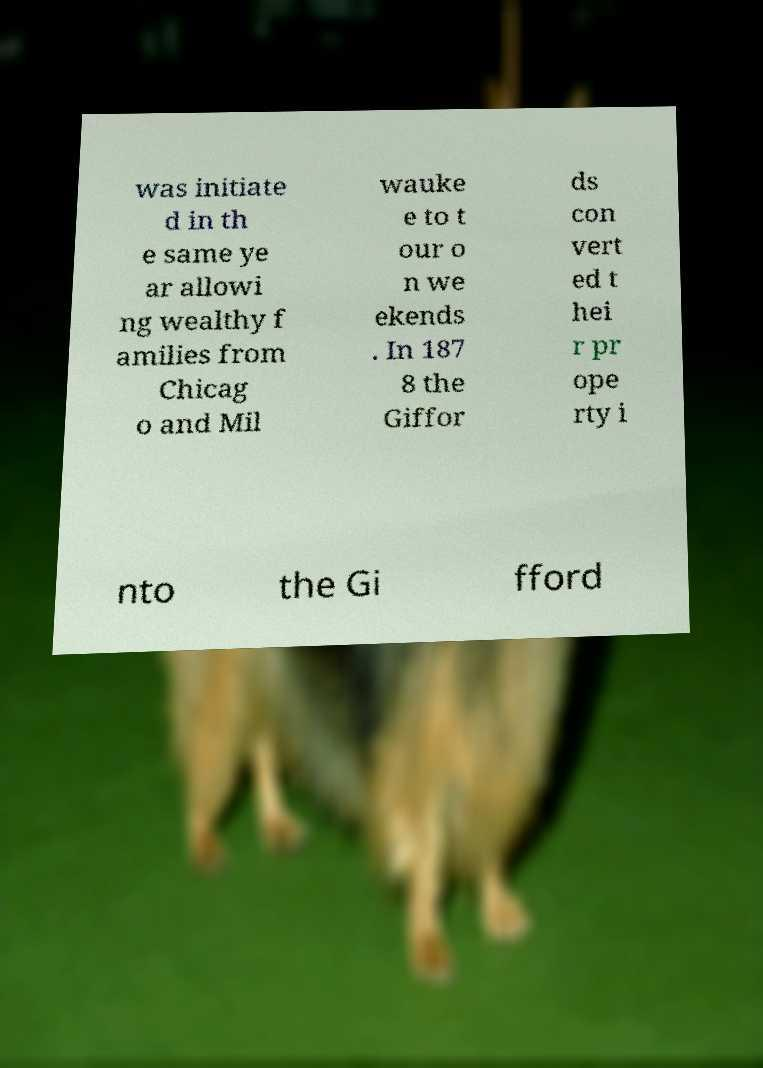I need the written content from this picture converted into text. Can you do that? was initiate d in th e same ye ar allowi ng wealthy f amilies from Chicag o and Mil wauke e to t our o n we ekends . In 187 8 the Giffor ds con vert ed t hei r pr ope rty i nto the Gi fford 